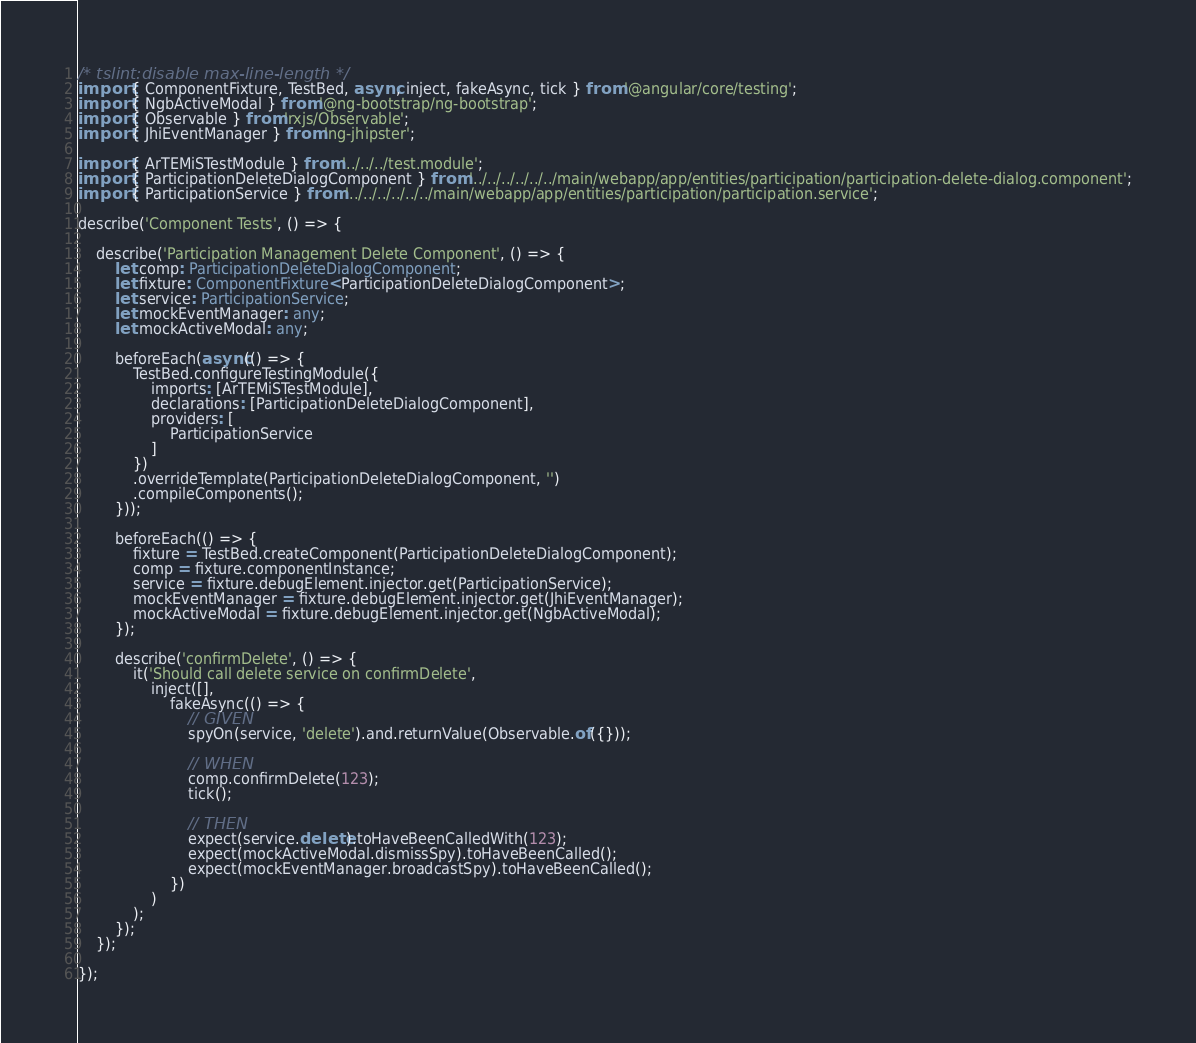Convert code to text. <code><loc_0><loc_0><loc_500><loc_500><_TypeScript_>/* tslint:disable max-line-length */
import { ComponentFixture, TestBed, async, inject, fakeAsync, tick } from '@angular/core/testing';
import { NgbActiveModal } from '@ng-bootstrap/ng-bootstrap';
import { Observable } from 'rxjs/Observable';
import { JhiEventManager } from 'ng-jhipster';

import { ArTEMiSTestModule } from '../../../test.module';
import { ParticipationDeleteDialogComponent } from '../../../../../../main/webapp/app/entities/participation/participation-delete-dialog.component';
import { ParticipationService } from '../../../../../../main/webapp/app/entities/participation/participation.service';

describe('Component Tests', () => {

    describe('Participation Management Delete Component', () => {
        let comp: ParticipationDeleteDialogComponent;
        let fixture: ComponentFixture<ParticipationDeleteDialogComponent>;
        let service: ParticipationService;
        let mockEventManager: any;
        let mockActiveModal: any;

        beforeEach(async(() => {
            TestBed.configureTestingModule({
                imports: [ArTEMiSTestModule],
                declarations: [ParticipationDeleteDialogComponent],
                providers: [
                    ParticipationService
                ]
            })
            .overrideTemplate(ParticipationDeleteDialogComponent, '')
            .compileComponents();
        }));

        beforeEach(() => {
            fixture = TestBed.createComponent(ParticipationDeleteDialogComponent);
            comp = fixture.componentInstance;
            service = fixture.debugElement.injector.get(ParticipationService);
            mockEventManager = fixture.debugElement.injector.get(JhiEventManager);
            mockActiveModal = fixture.debugElement.injector.get(NgbActiveModal);
        });

        describe('confirmDelete', () => {
            it('Should call delete service on confirmDelete',
                inject([],
                    fakeAsync(() => {
                        // GIVEN
                        spyOn(service, 'delete').and.returnValue(Observable.of({}));

                        // WHEN
                        comp.confirmDelete(123);
                        tick();

                        // THEN
                        expect(service.delete).toHaveBeenCalledWith(123);
                        expect(mockActiveModal.dismissSpy).toHaveBeenCalled();
                        expect(mockEventManager.broadcastSpy).toHaveBeenCalled();
                    })
                )
            );
        });
    });

});
</code> 